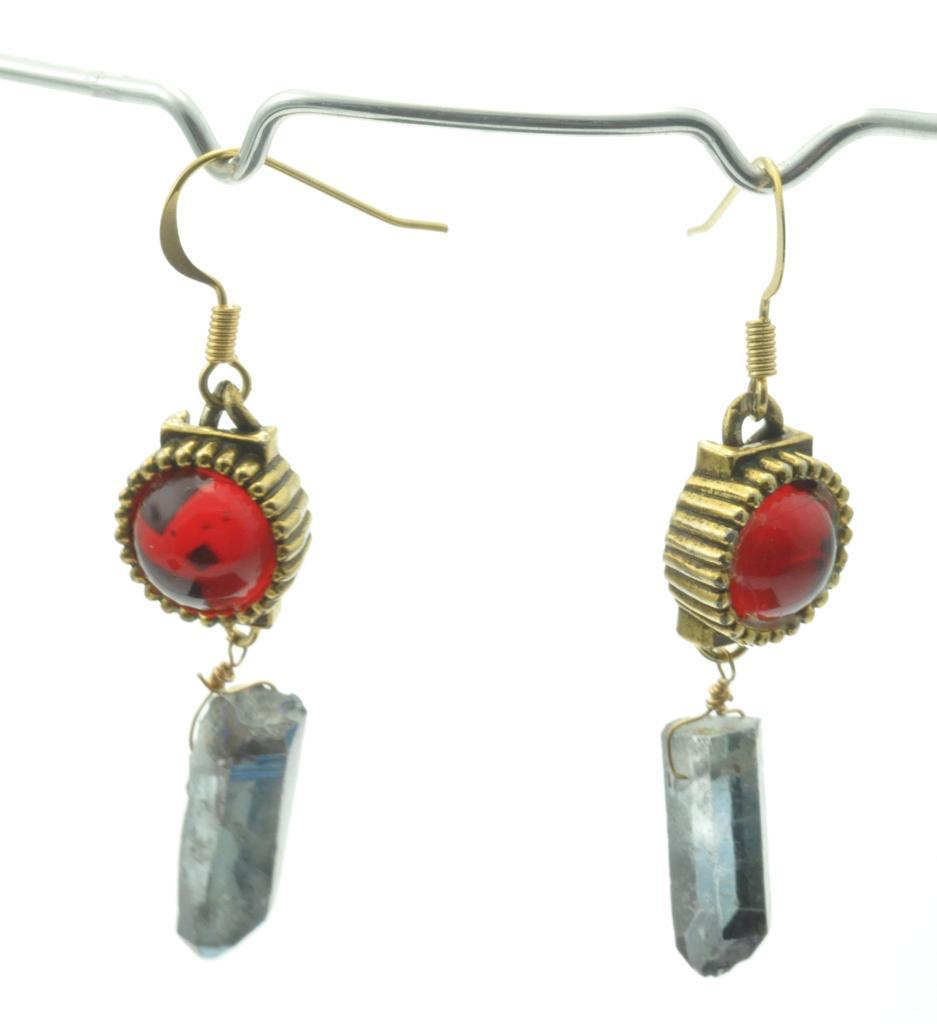In one or two sentences, can you explain what this image depicts? In this image there are two earrings on the hanger. 